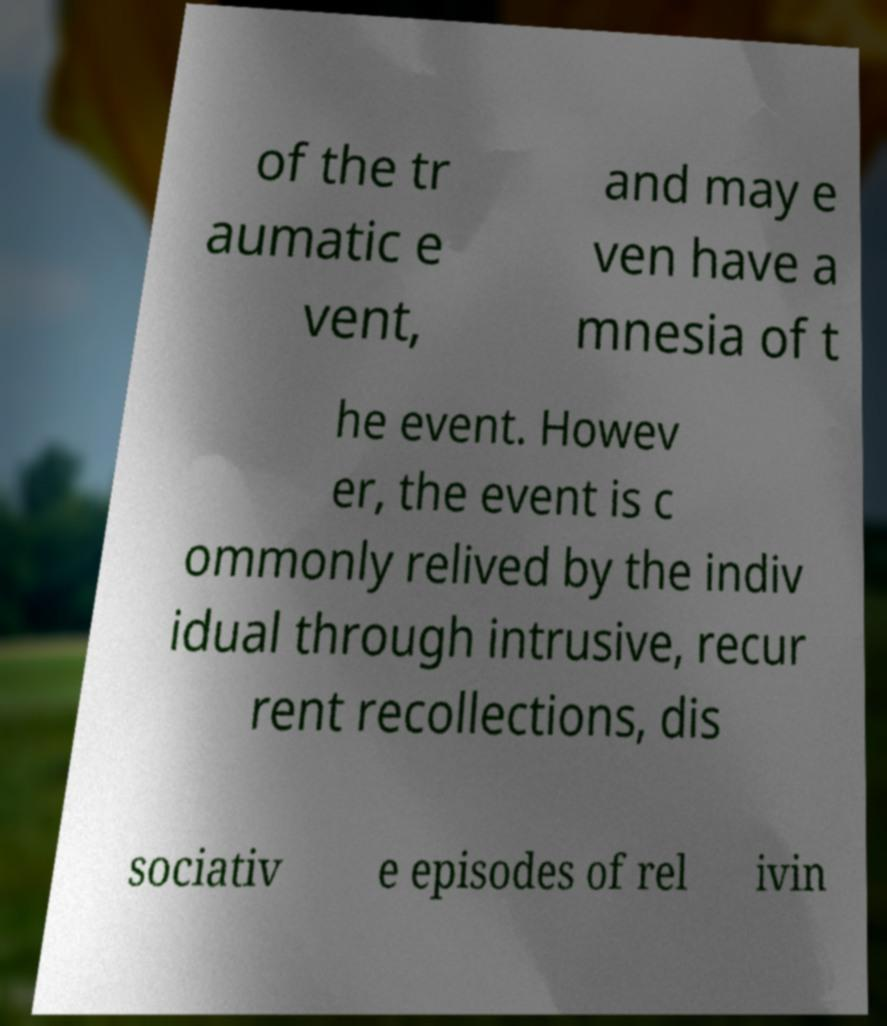I need the written content from this picture converted into text. Can you do that? of the tr aumatic e vent, and may e ven have a mnesia of t he event. Howev er, the event is c ommonly relived by the indiv idual through intrusive, recur rent recollections, dis sociativ e episodes of rel ivin 